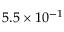<formula> <loc_0><loc_0><loc_500><loc_500>5 . 5 \times 1 0 ^ { - 1 }</formula> 